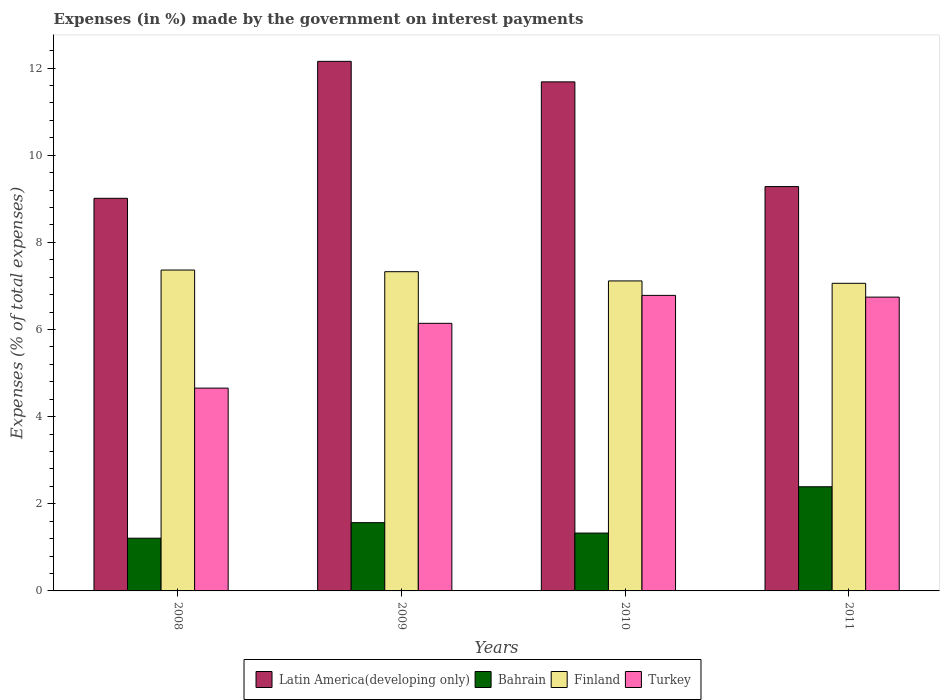Are the number of bars per tick equal to the number of legend labels?
Provide a short and direct response. Yes. Are the number of bars on each tick of the X-axis equal?
Your response must be concise. Yes. How many bars are there on the 4th tick from the right?
Your answer should be very brief. 4. What is the label of the 3rd group of bars from the left?
Offer a very short reply. 2010. What is the percentage of expenses made by the government on interest payments in Finland in 2010?
Your answer should be very brief. 7.11. Across all years, what is the maximum percentage of expenses made by the government on interest payments in Latin America(developing only)?
Your answer should be very brief. 12.15. Across all years, what is the minimum percentage of expenses made by the government on interest payments in Bahrain?
Provide a short and direct response. 1.21. What is the total percentage of expenses made by the government on interest payments in Finland in the graph?
Offer a very short reply. 28.87. What is the difference between the percentage of expenses made by the government on interest payments in Bahrain in 2008 and that in 2010?
Give a very brief answer. -0.12. What is the difference between the percentage of expenses made by the government on interest payments in Finland in 2011 and the percentage of expenses made by the government on interest payments in Latin America(developing only) in 2008?
Ensure brevity in your answer.  -1.95. What is the average percentage of expenses made by the government on interest payments in Latin America(developing only) per year?
Give a very brief answer. 10.53. In the year 2008, what is the difference between the percentage of expenses made by the government on interest payments in Bahrain and percentage of expenses made by the government on interest payments in Finland?
Ensure brevity in your answer.  -6.15. What is the ratio of the percentage of expenses made by the government on interest payments in Finland in 2008 to that in 2010?
Your answer should be compact. 1.04. What is the difference between the highest and the second highest percentage of expenses made by the government on interest payments in Latin America(developing only)?
Give a very brief answer. 0.47. What is the difference between the highest and the lowest percentage of expenses made by the government on interest payments in Finland?
Give a very brief answer. 0.3. Is the sum of the percentage of expenses made by the government on interest payments in Finland in 2009 and 2011 greater than the maximum percentage of expenses made by the government on interest payments in Turkey across all years?
Give a very brief answer. Yes. What does the 4th bar from the left in 2008 represents?
Ensure brevity in your answer.  Turkey. How many bars are there?
Offer a terse response. 16. What is the difference between two consecutive major ticks on the Y-axis?
Offer a terse response. 2. Does the graph contain grids?
Provide a short and direct response. No. What is the title of the graph?
Keep it short and to the point. Expenses (in %) made by the government on interest payments. What is the label or title of the X-axis?
Ensure brevity in your answer.  Years. What is the label or title of the Y-axis?
Ensure brevity in your answer.  Expenses (% of total expenses). What is the Expenses (% of total expenses) in Latin America(developing only) in 2008?
Provide a succinct answer. 9.01. What is the Expenses (% of total expenses) of Bahrain in 2008?
Make the answer very short. 1.21. What is the Expenses (% of total expenses) of Finland in 2008?
Your response must be concise. 7.36. What is the Expenses (% of total expenses) in Turkey in 2008?
Make the answer very short. 4.65. What is the Expenses (% of total expenses) in Latin America(developing only) in 2009?
Your response must be concise. 12.15. What is the Expenses (% of total expenses) of Bahrain in 2009?
Make the answer very short. 1.57. What is the Expenses (% of total expenses) in Finland in 2009?
Provide a succinct answer. 7.33. What is the Expenses (% of total expenses) of Turkey in 2009?
Keep it short and to the point. 6.14. What is the Expenses (% of total expenses) in Latin America(developing only) in 2010?
Your answer should be compact. 11.68. What is the Expenses (% of total expenses) in Bahrain in 2010?
Provide a succinct answer. 1.33. What is the Expenses (% of total expenses) in Finland in 2010?
Ensure brevity in your answer.  7.11. What is the Expenses (% of total expenses) of Turkey in 2010?
Provide a short and direct response. 6.78. What is the Expenses (% of total expenses) of Latin America(developing only) in 2011?
Keep it short and to the point. 9.28. What is the Expenses (% of total expenses) of Bahrain in 2011?
Keep it short and to the point. 2.39. What is the Expenses (% of total expenses) in Finland in 2011?
Make the answer very short. 7.06. What is the Expenses (% of total expenses) of Turkey in 2011?
Offer a terse response. 6.74. Across all years, what is the maximum Expenses (% of total expenses) in Latin America(developing only)?
Provide a short and direct response. 12.15. Across all years, what is the maximum Expenses (% of total expenses) of Bahrain?
Ensure brevity in your answer.  2.39. Across all years, what is the maximum Expenses (% of total expenses) in Finland?
Provide a short and direct response. 7.36. Across all years, what is the maximum Expenses (% of total expenses) of Turkey?
Provide a short and direct response. 6.78. Across all years, what is the minimum Expenses (% of total expenses) in Latin America(developing only)?
Your answer should be very brief. 9.01. Across all years, what is the minimum Expenses (% of total expenses) in Bahrain?
Your answer should be compact. 1.21. Across all years, what is the minimum Expenses (% of total expenses) of Finland?
Your answer should be compact. 7.06. Across all years, what is the minimum Expenses (% of total expenses) in Turkey?
Make the answer very short. 4.65. What is the total Expenses (% of total expenses) of Latin America(developing only) in the graph?
Provide a short and direct response. 42.13. What is the total Expenses (% of total expenses) in Bahrain in the graph?
Keep it short and to the point. 6.49. What is the total Expenses (% of total expenses) of Finland in the graph?
Give a very brief answer. 28.87. What is the total Expenses (% of total expenses) in Turkey in the graph?
Your answer should be very brief. 24.32. What is the difference between the Expenses (% of total expenses) in Latin America(developing only) in 2008 and that in 2009?
Offer a terse response. -3.14. What is the difference between the Expenses (% of total expenses) of Bahrain in 2008 and that in 2009?
Your answer should be very brief. -0.36. What is the difference between the Expenses (% of total expenses) of Finland in 2008 and that in 2009?
Give a very brief answer. 0.04. What is the difference between the Expenses (% of total expenses) of Turkey in 2008 and that in 2009?
Your answer should be very brief. -1.49. What is the difference between the Expenses (% of total expenses) in Latin America(developing only) in 2008 and that in 2010?
Ensure brevity in your answer.  -2.67. What is the difference between the Expenses (% of total expenses) in Bahrain in 2008 and that in 2010?
Provide a short and direct response. -0.12. What is the difference between the Expenses (% of total expenses) in Finland in 2008 and that in 2010?
Make the answer very short. 0.25. What is the difference between the Expenses (% of total expenses) in Turkey in 2008 and that in 2010?
Make the answer very short. -2.13. What is the difference between the Expenses (% of total expenses) of Latin America(developing only) in 2008 and that in 2011?
Your response must be concise. -0.27. What is the difference between the Expenses (% of total expenses) in Bahrain in 2008 and that in 2011?
Make the answer very short. -1.18. What is the difference between the Expenses (% of total expenses) in Finland in 2008 and that in 2011?
Your answer should be compact. 0.3. What is the difference between the Expenses (% of total expenses) in Turkey in 2008 and that in 2011?
Offer a terse response. -2.09. What is the difference between the Expenses (% of total expenses) in Latin America(developing only) in 2009 and that in 2010?
Your response must be concise. 0.47. What is the difference between the Expenses (% of total expenses) of Bahrain in 2009 and that in 2010?
Provide a succinct answer. 0.24. What is the difference between the Expenses (% of total expenses) of Finland in 2009 and that in 2010?
Ensure brevity in your answer.  0.21. What is the difference between the Expenses (% of total expenses) of Turkey in 2009 and that in 2010?
Your answer should be very brief. -0.64. What is the difference between the Expenses (% of total expenses) of Latin America(developing only) in 2009 and that in 2011?
Offer a very short reply. 2.87. What is the difference between the Expenses (% of total expenses) in Bahrain in 2009 and that in 2011?
Make the answer very short. -0.82. What is the difference between the Expenses (% of total expenses) of Finland in 2009 and that in 2011?
Your answer should be compact. 0.27. What is the difference between the Expenses (% of total expenses) in Turkey in 2009 and that in 2011?
Give a very brief answer. -0.6. What is the difference between the Expenses (% of total expenses) of Latin America(developing only) in 2010 and that in 2011?
Your response must be concise. 2.4. What is the difference between the Expenses (% of total expenses) of Bahrain in 2010 and that in 2011?
Your answer should be compact. -1.06. What is the difference between the Expenses (% of total expenses) of Finland in 2010 and that in 2011?
Ensure brevity in your answer.  0.05. What is the difference between the Expenses (% of total expenses) in Turkey in 2010 and that in 2011?
Offer a very short reply. 0.04. What is the difference between the Expenses (% of total expenses) of Latin America(developing only) in 2008 and the Expenses (% of total expenses) of Bahrain in 2009?
Offer a terse response. 7.44. What is the difference between the Expenses (% of total expenses) in Latin America(developing only) in 2008 and the Expenses (% of total expenses) in Finland in 2009?
Give a very brief answer. 1.68. What is the difference between the Expenses (% of total expenses) in Latin America(developing only) in 2008 and the Expenses (% of total expenses) in Turkey in 2009?
Make the answer very short. 2.87. What is the difference between the Expenses (% of total expenses) in Bahrain in 2008 and the Expenses (% of total expenses) in Finland in 2009?
Offer a terse response. -6.12. What is the difference between the Expenses (% of total expenses) of Bahrain in 2008 and the Expenses (% of total expenses) of Turkey in 2009?
Your answer should be compact. -4.93. What is the difference between the Expenses (% of total expenses) of Finland in 2008 and the Expenses (% of total expenses) of Turkey in 2009?
Ensure brevity in your answer.  1.22. What is the difference between the Expenses (% of total expenses) in Latin America(developing only) in 2008 and the Expenses (% of total expenses) in Bahrain in 2010?
Your answer should be compact. 7.68. What is the difference between the Expenses (% of total expenses) of Latin America(developing only) in 2008 and the Expenses (% of total expenses) of Finland in 2010?
Give a very brief answer. 1.9. What is the difference between the Expenses (% of total expenses) of Latin America(developing only) in 2008 and the Expenses (% of total expenses) of Turkey in 2010?
Ensure brevity in your answer.  2.23. What is the difference between the Expenses (% of total expenses) in Bahrain in 2008 and the Expenses (% of total expenses) in Finland in 2010?
Ensure brevity in your answer.  -5.9. What is the difference between the Expenses (% of total expenses) in Bahrain in 2008 and the Expenses (% of total expenses) in Turkey in 2010?
Your response must be concise. -5.57. What is the difference between the Expenses (% of total expenses) in Finland in 2008 and the Expenses (% of total expenses) in Turkey in 2010?
Give a very brief answer. 0.58. What is the difference between the Expenses (% of total expenses) in Latin America(developing only) in 2008 and the Expenses (% of total expenses) in Bahrain in 2011?
Ensure brevity in your answer.  6.62. What is the difference between the Expenses (% of total expenses) of Latin America(developing only) in 2008 and the Expenses (% of total expenses) of Finland in 2011?
Offer a very short reply. 1.95. What is the difference between the Expenses (% of total expenses) of Latin America(developing only) in 2008 and the Expenses (% of total expenses) of Turkey in 2011?
Ensure brevity in your answer.  2.27. What is the difference between the Expenses (% of total expenses) in Bahrain in 2008 and the Expenses (% of total expenses) in Finland in 2011?
Your answer should be very brief. -5.85. What is the difference between the Expenses (% of total expenses) in Bahrain in 2008 and the Expenses (% of total expenses) in Turkey in 2011?
Provide a succinct answer. -5.53. What is the difference between the Expenses (% of total expenses) in Finland in 2008 and the Expenses (% of total expenses) in Turkey in 2011?
Ensure brevity in your answer.  0.62. What is the difference between the Expenses (% of total expenses) in Latin America(developing only) in 2009 and the Expenses (% of total expenses) in Bahrain in 2010?
Your answer should be very brief. 10.83. What is the difference between the Expenses (% of total expenses) in Latin America(developing only) in 2009 and the Expenses (% of total expenses) in Finland in 2010?
Keep it short and to the point. 5.04. What is the difference between the Expenses (% of total expenses) in Latin America(developing only) in 2009 and the Expenses (% of total expenses) in Turkey in 2010?
Ensure brevity in your answer.  5.37. What is the difference between the Expenses (% of total expenses) in Bahrain in 2009 and the Expenses (% of total expenses) in Finland in 2010?
Ensure brevity in your answer.  -5.55. What is the difference between the Expenses (% of total expenses) in Bahrain in 2009 and the Expenses (% of total expenses) in Turkey in 2010?
Your answer should be very brief. -5.22. What is the difference between the Expenses (% of total expenses) in Finland in 2009 and the Expenses (% of total expenses) in Turkey in 2010?
Give a very brief answer. 0.54. What is the difference between the Expenses (% of total expenses) in Latin America(developing only) in 2009 and the Expenses (% of total expenses) in Bahrain in 2011?
Offer a terse response. 9.76. What is the difference between the Expenses (% of total expenses) of Latin America(developing only) in 2009 and the Expenses (% of total expenses) of Finland in 2011?
Your response must be concise. 5.09. What is the difference between the Expenses (% of total expenses) of Latin America(developing only) in 2009 and the Expenses (% of total expenses) of Turkey in 2011?
Ensure brevity in your answer.  5.41. What is the difference between the Expenses (% of total expenses) in Bahrain in 2009 and the Expenses (% of total expenses) in Finland in 2011?
Give a very brief answer. -5.49. What is the difference between the Expenses (% of total expenses) in Bahrain in 2009 and the Expenses (% of total expenses) in Turkey in 2011?
Offer a very short reply. -5.18. What is the difference between the Expenses (% of total expenses) of Finland in 2009 and the Expenses (% of total expenses) of Turkey in 2011?
Give a very brief answer. 0.58. What is the difference between the Expenses (% of total expenses) of Latin America(developing only) in 2010 and the Expenses (% of total expenses) of Bahrain in 2011?
Offer a very short reply. 9.29. What is the difference between the Expenses (% of total expenses) of Latin America(developing only) in 2010 and the Expenses (% of total expenses) of Finland in 2011?
Your answer should be compact. 4.62. What is the difference between the Expenses (% of total expenses) of Latin America(developing only) in 2010 and the Expenses (% of total expenses) of Turkey in 2011?
Give a very brief answer. 4.94. What is the difference between the Expenses (% of total expenses) of Bahrain in 2010 and the Expenses (% of total expenses) of Finland in 2011?
Your answer should be very brief. -5.73. What is the difference between the Expenses (% of total expenses) in Bahrain in 2010 and the Expenses (% of total expenses) in Turkey in 2011?
Provide a short and direct response. -5.42. What is the difference between the Expenses (% of total expenses) in Finland in 2010 and the Expenses (% of total expenses) in Turkey in 2011?
Make the answer very short. 0.37. What is the average Expenses (% of total expenses) of Latin America(developing only) per year?
Offer a very short reply. 10.53. What is the average Expenses (% of total expenses) in Bahrain per year?
Ensure brevity in your answer.  1.62. What is the average Expenses (% of total expenses) in Finland per year?
Offer a terse response. 7.22. What is the average Expenses (% of total expenses) of Turkey per year?
Offer a very short reply. 6.08. In the year 2008, what is the difference between the Expenses (% of total expenses) of Latin America(developing only) and Expenses (% of total expenses) of Bahrain?
Your answer should be very brief. 7.8. In the year 2008, what is the difference between the Expenses (% of total expenses) in Latin America(developing only) and Expenses (% of total expenses) in Finland?
Make the answer very short. 1.65. In the year 2008, what is the difference between the Expenses (% of total expenses) of Latin America(developing only) and Expenses (% of total expenses) of Turkey?
Offer a terse response. 4.36. In the year 2008, what is the difference between the Expenses (% of total expenses) of Bahrain and Expenses (% of total expenses) of Finland?
Make the answer very short. -6.15. In the year 2008, what is the difference between the Expenses (% of total expenses) of Bahrain and Expenses (% of total expenses) of Turkey?
Offer a very short reply. -3.44. In the year 2008, what is the difference between the Expenses (% of total expenses) of Finland and Expenses (% of total expenses) of Turkey?
Your answer should be very brief. 2.71. In the year 2009, what is the difference between the Expenses (% of total expenses) in Latin America(developing only) and Expenses (% of total expenses) in Bahrain?
Your response must be concise. 10.59. In the year 2009, what is the difference between the Expenses (% of total expenses) in Latin America(developing only) and Expenses (% of total expenses) in Finland?
Offer a very short reply. 4.83. In the year 2009, what is the difference between the Expenses (% of total expenses) in Latin America(developing only) and Expenses (% of total expenses) in Turkey?
Your answer should be compact. 6.01. In the year 2009, what is the difference between the Expenses (% of total expenses) in Bahrain and Expenses (% of total expenses) in Finland?
Your answer should be very brief. -5.76. In the year 2009, what is the difference between the Expenses (% of total expenses) of Bahrain and Expenses (% of total expenses) of Turkey?
Your answer should be very brief. -4.58. In the year 2009, what is the difference between the Expenses (% of total expenses) in Finland and Expenses (% of total expenses) in Turkey?
Keep it short and to the point. 1.19. In the year 2010, what is the difference between the Expenses (% of total expenses) in Latin America(developing only) and Expenses (% of total expenses) in Bahrain?
Offer a very short reply. 10.36. In the year 2010, what is the difference between the Expenses (% of total expenses) of Latin America(developing only) and Expenses (% of total expenses) of Finland?
Offer a terse response. 4.57. In the year 2010, what is the difference between the Expenses (% of total expenses) of Latin America(developing only) and Expenses (% of total expenses) of Turkey?
Your answer should be very brief. 4.9. In the year 2010, what is the difference between the Expenses (% of total expenses) in Bahrain and Expenses (% of total expenses) in Finland?
Your response must be concise. -5.79. In the year 2010, what is the difference between the Expenses (% of total expenses) in Bahrain and Expenses (% of total expenses) in Turkey?
Provide a succinct answer. -5.45. In the year 2010, what is the difference between the Expenses (% of total expenses) of Finland and Expenses (% of total expenses) of Turkey?
Your response must be concise. 0.33. In the year 2011, what is the difference between the Expenses (% of total expenses) in Latin America(developing only) and Expenses (% of total expenses) in Bahrain?
Ensure brevity in your answer.  6.89. In the year 2011, what is the difference between the Expenses (% of total expenses) in Latin America(developing only) and Expenses (% of total expenses) in Finland?
Ensure brevity in your answer.  2.22. In the year 2011, what is the difference between the Expenses (% of total expenses) in Latin America(developing only) and Expenses (% of total expenses) in Turkey?
Your answer should be compact. 2.54. In the year 2011, what is the difference between the Expenses (% of total expenses) of Bahrain and Expenses (% of total expenses) of Finland?
Your response must be concise. -4.67. In the year 2011, what is the difference between the Expenses (% of total expenses) of Bahrain and Expenses (% of total expenses) of Turkey?
Keep it short and to the point. -4.35. In the year 2011, what is the difference between the Expenses (% of total expenses) of Finland and Expenses (% of total expenses) of Turkey?
Offer a very short reply. 0.32. What is the ratio of the Expenses (% of total expenses) of Latin America(developing only) in 2008 to that in 2009?
Your answer should be compact. 0.74. What is the ratio of the Expenses (% of total expenses) of Bahrain in 2008 to that in 2009?
Keep it short and to the point. 0.77. What is the ratio of the Expenses (% of total expenses) of Finland in 2008 to that in 2009?
Keep it short and to the point. 1.01. What is the ratio of the Expenses (% of total expenses) in Turkey in 2008 to that in 2009?
Give a very brief answer. 0.76. What is the ratio of the Expenses (% of total expenses) of Latin America(developing only) in 2008 to that in 2010?
Give a very brief answer. 0.77. What is the ratio of the Expenses (% of total expenses) in Bahrain in 2008 to that in 2010?
Your answer should be very brief. 0.91. What is the ratio of the Expenses (% of total expenses) in Finland in 2008 to that in 2010?
Your answer should be very brief. 1.04. What is the ratio of the Expenses (% of total expenses) in Turkey in 2008 to that in 2010?
Offer a very short reply. 0.69. What is the ratio of the Expenses (% of total expenses) in Latin America(developing only) in 2008 to that in 2011?
Give a very brief answer. 0.97. What is the ratio of the Expenses (% of total expenses) in Bahrain in 2008 to that in 2011?
Your response must be concise. 0.51. What is the ratio of the Expenses (% of total expenses) of Finland in 2008 to that in 2011?
Provide a short and direct response. 1.04. What is the ratio of the Expenses (% of total expenses) of Turkey in 2008 to that in 2011?
Keep it short and to the point. 0.69. What is the ratio of the Expenses (% of total expenses) in Latin America(developing only) in 2009 to that in 2010?
Your response must be concise. 1.04. What is the ratio of the Expenses (% of total expenses) of Bahrain in 2009 to that in 2010?
Provide a succinct answer. 1.18. What is the ratio of the Expenses (% of total expenses) in Finland in 2009 to that in 2010?
Make the answer very short. 1.03. What is the ratio of the Expenses (% of total expenses) of Turkey in 2009 to that in 2010?
Offer a terse response. 0.91. What is the ratio of the Expenses (% of total expenses) in Latin America(developing only) in 2009 to that in 2011?
Offer a terse response. 1.31. What is the ratio of the Expenses (% of total expenses) of Bahrain in 2009 to that in 2011?
Your answer should be very brief. 0.66. What is the ratio of the Expenses (% of total expenses) in Finland in 2009 to that in 2011?
Offer a terse response. 1.04. What is the ratio of the Expenses (% of total expenses) in Turkey in 2009 to that in 2011?
Give a very brief answer. 0.91. What is the ratio of the Expenses (% of total expenses) of Latin America(developing only) in 2010 to that in 2011?
Your answer should be very brief. 1.26. What is the ratio of the Expenses (% of total expenses) in Bahrain in 2010 to that in 2011?
Your response must be concise. 0.56. What is the ratio of the Expenses (% of total expenses) in Finland in 2010 to that in 2011?
Offer a very short reply. 1.01. What is the ratio of the Expenses (% of total expenses) of Turkey in 2010 to that in 2011?
Ensure brevity in your answer.  1.01. What is the difference between the highest and the second highest Expenses (% of total expenses) in Latin America(developing only)?
Give a very brief answer. 0.47. What is the difference between the highest and the second highest Expenses (% of total expenses) in Bahrain?
Provide a short and direct response. 0.82. What is the difference between the highest and the second highest Expenses (% of total expenses) in Finland?
Give a very brief answer. 0.04. What is the difference between the highest and the second highest Expenses (% of total expenses) of Turkey?
Offer a terse response. 0.04. What is the difference between the highest and the lowest Expenses (% of total expenses) in Latin America(developing only)?
Offer a terse response. 3.14. What is the difference between the highest and the lowest Expenses (% of total expenses) of Bahrain?
Provide a short and direct response. 1.18. What is the difference between the highest and the lowest Expenses (% of total expenses) of Finland?
Ensure brevity in your answer.  0.3. What is the difference between the highest and the lowest Expenses (% of total expenses) in Turkey?
Give a very brief answer. 2.13. 